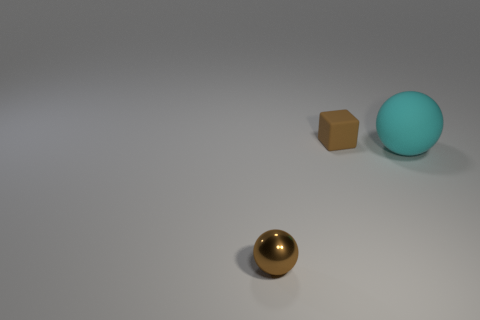Does the sphere right of the cube have the same size as the small brown sphere?
Offer a terse response. No. There is a matte thing in front of the small brown thing right of the shiny thing; how many small brown matte blocks are behind it?
Give a very brief answer. 1. What size is the thing that is both in front of the cube and left of the big cyan matte object?
Keep it short and to the point. Small. What number of other things are there of the same shape as the tiny brown matte thing?
Your response must be concise. 0. There is a small brown metallic object; what number of brown things are on the right side of it?
Provide a succinct answer. 1. Are there fewer tiny brown metal balls to the left of the brown metal thing than tiny metallic spheres that are behind the big cyan thing?
Offer a terse response. No. What is the shape of the brown thing that is behind the tiny object on the left side of the matte thing that is behind the big cyan sphere?
Give a very brief answer. Cube. There is a thing that is left of the large sphere and in front of the brown cube; what shape is it?
Your answer should be compact. Sphere. Are there any blocks that have the same material as the cyan object?
Offer a terse response. Yes. There is a thing that is the same color as the tiny sphere; what is its size?
Keep it short and to the point. Small. 